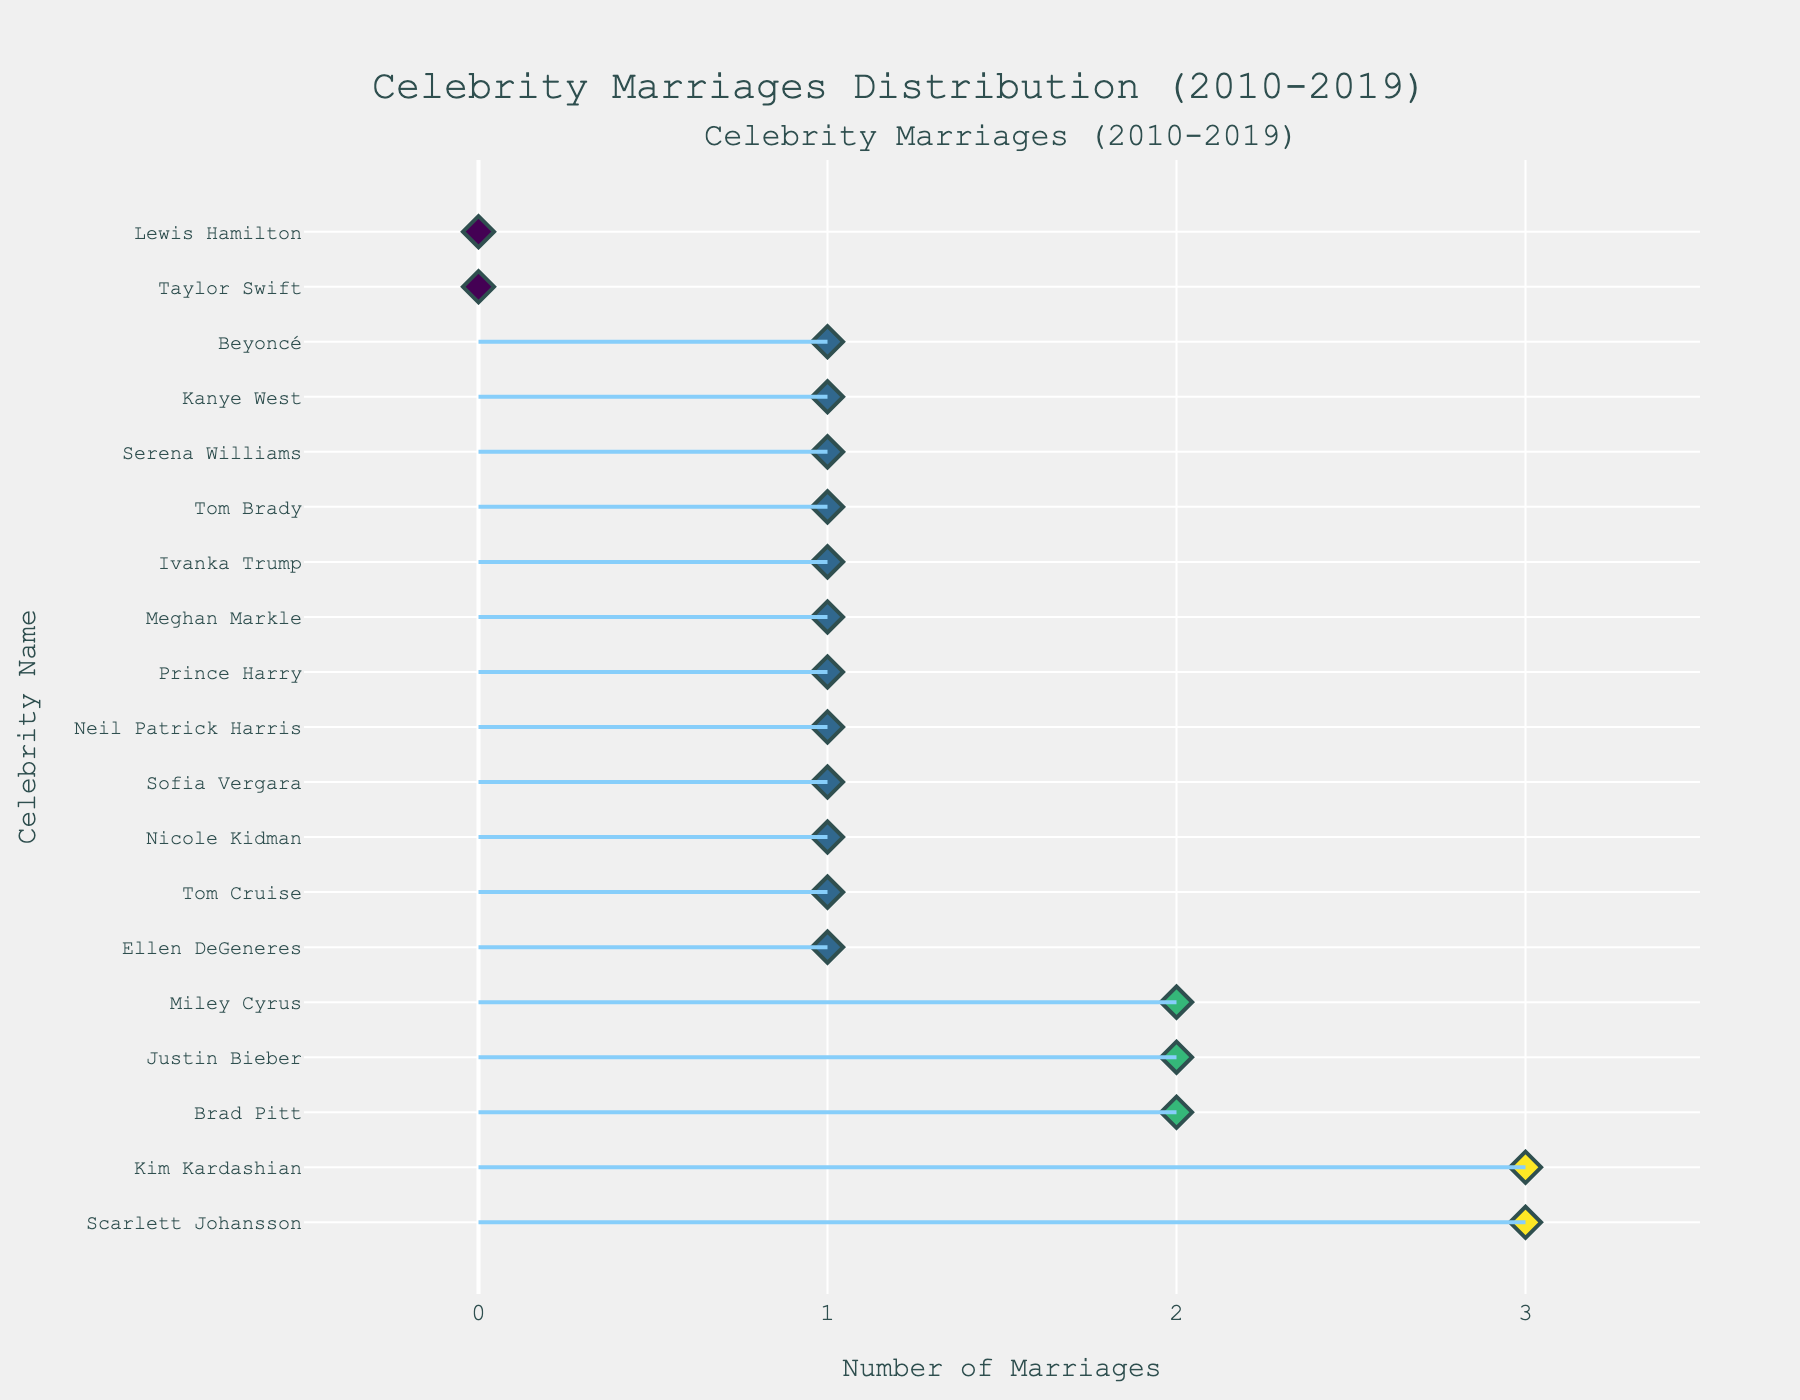Which celebrity has the most number of marriages according to the plot? Look at the dot plot, find the point farthest to the right. The corresponding celebrity name is at the same y-coordinate.
Answer: Kim Kardashian and Scarlett Johansson How many celebrities in the plot belong to the Film industry? Count the number of points where the text information shows "Film" when hovering over the point in the plot.
Answer: 4 Which age group had the highest number of marriages overall? Sum the "EventCount" for each age group and compare. From the plot data, count all marriages in each age group.
Answer: 30-39 What’s the total number of marriages for celebrities in the Sports industry? Add up the "EventCount" for all celebrities labeled with "Sports" in the plot. Serena Williams (1) + Tom Brady (1) + Lewis Hamilton (0) = 2.
Answer: 2 Compare the number of marriages between celebrities aged 20-29 and those aged 40-49. Which group had more? Add up the "EventCount" for each age group. For 20-29: Scarlett Johansson (3), Miley Cyrus (2), Justin Bieber (2), Taylor Swift (0) = 7. For 40-49: Brad Pitt (2), Tom Brady (1), Sofia Vergara (1), Nicole Kidman (1) = 5.
Answer: 20-29 Which celebrity from the Music industry had the same number of marriages as Scarlett Johansson? Identify Scarlett Johansson's count (3), then find another point with the same count labeled "Music".
Answer: Kim Kardashian What's the difference in the number of marriages between Kanye West and Tom Brady? Subtract the number of marriages for each (Kanye West: 1, Tom Brady: 1), both are equal so the difference is 0.
Answer: 0 Which industry has the least number of marriages among the listed celebrities? Sum the "EventCount" for each industry and find the lowest total. Politics (Ivanka Trump: 1) and Reality TV (Kim Kardashian: 3). Politics has fewer marriages.
Answer: Politics How many celebrities in the Music industry had zero marriages? Find and count the points labeled "Music" with an "EventCount" of 0. In the provided data, only Lewis Hamilton had 0 marriages.
Answer: 1 